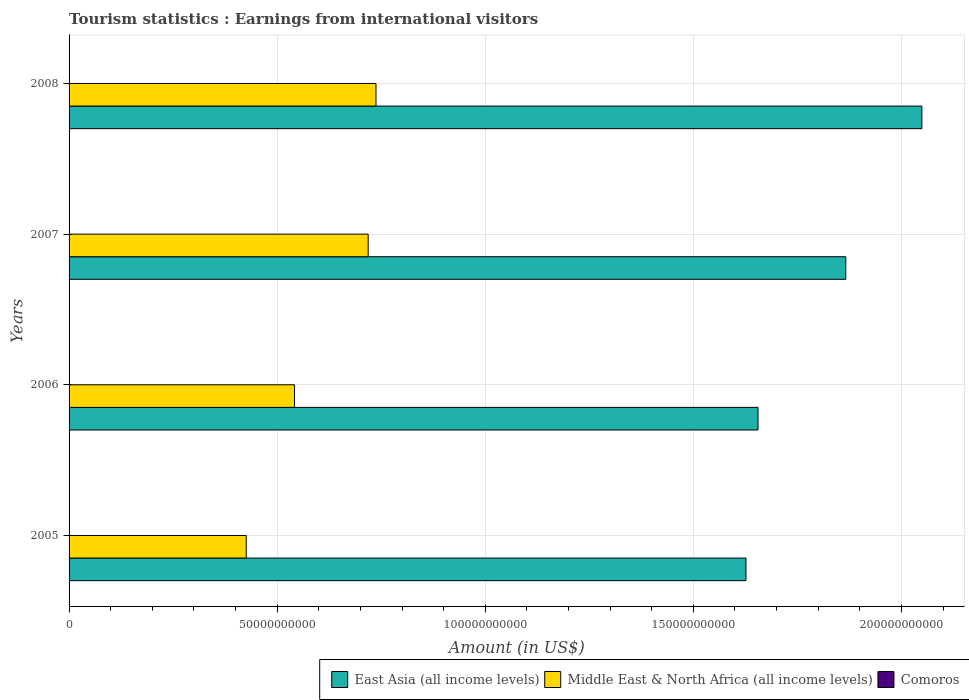Are the number of bars per tick equal to the number of legend labels?
Ensure brevity in your answer.  Yes. Are the number of bars on each tick of the Y-axis equal?
Provide a succinct answer. Yes. How many bars are there on the 2nd tick from the top?
Offer a very short reply. 3. How many bars are there on the 4th tick from the bottom?
Ensure brevity in your answer.  3. What is the label of the 4th group of bars from the top?
Keep it short and to the point. 2005. In how many cases, is the number of bars for a given year not equal to the number of legend labels?
Your answer should be very brief. 0. What is the earnings from international visitors in East Asia (all income levels) in 2007?
Keep it short and to the point. 1.87e+11. Across all years, what is the maximum earnings from international visitors in Comoros?
Your response must be concise. 3.10e+07. Across all years, what is the minimum earnings from international visitors in East Asia (all income levels)?
Offer a very short reply. 1.63e+11. In which year was the earnings from international visitors in Middle East & North Africa (all income levels) maximum?
Offer a very short reply. 2008. What is the total earnings from international visitors in East Asia (all income levels) in the graph?
Give a very brief answer. 7.20e+11. What is the difference between the earnings from international visitors in Comoros in 2005 and that in 2006?
Offer a very short reply. -4.00e+06. What is the difference between the earnings from international visitors in Middle East & North Africa (all income levels) in 2005 and the earnings from international visitors in East Asia (all income levels) in 2007?
Give a very brief answer. -1.44e+11. What is the average earnings from international visitors in East Asia (all income levels) per year?
Your answer should be very brief. 1.80e+11. In the year 2007, what is the difference between the earnings from international visitors in Middle East & North Africa (all income levels) and earnings from international visitors in East Asia (all income levels)?
Your answer should be compact. -1.15e+11. What is the ratio of the earnings from international visitors in Middle East & North Africa (all income levels) in 2005 to that in 2007?
Provide a succinct answer. 0.59. What is the difference between the highest and the second highest earnings from international visitors in Middle East & North Africa (all income levels)?
Make the answer very short. 1.88e+09. What is the difference between the highest and the lowest earnings from international visitors in Middle East & North Africa (all income levels)?
Your response must be concise. 3.12e+1. Is the sum of the earnings from international visitors in East Asia (all income levels) in 2005 and 2006 greater than the maximum earnings from international visitors in Comoros across all years?
Your response must be concise. Yes. What does the 1st bar from the top in 2006 represents?
Provide a short and direct response. Comoros. What does the 3rd bar from the bottom in 2006 represents?
Make the answer very short. Comoros. Is it the case that in every year, the sum of the earnings from international visitors in Middle East & North Africa (all income levels) and earnings from international visitors in East Asia (all income levels) is greater than the earnings from international visitors in Comoros?
Your response must be concise. Yes. How many bars are there?
Keep it short and to the point. 12. How many years are there in the graph?
Make the answer very short. 4. Are the values on the major ticks of X-axis written in scientific E-notation?
Ensure brevity in your answer.  No. Does the graph contain any zero values?
Ensure brevity in your answer.  No. Where does the legend appear in the graph?
Ensure brevity in your answer.  Bottom right. How many legend labels are there?
Provide a succinct answer. 3. What is the title of the graph?
Offer a terse response. Tourism statistics : Earnings from international visitors. What is the label or title of the X-axis?
Your answer should be very brief. Amount (in US$). What is the Amount (in US$) of East Asia (all income levels) in 2005?
Offer a very short reply. 1.63e+11. What is the Amount (in US$) in Middle East & North Africa (all income levels) in 2005?
Ensure brevity in your answer.  4.26e+1. What is the Amount (in US$) of East Asia (all income levels) in 2006?
Ensure brevity in your answer.  1.66e+11. What is the Amount (in US$) in Middle East & North Africa (all income levels) in 2006?
Your answer should be very brief. 5.42e+1. What is the Amount (in US$) in Comoros in 2006?
Give a very brief answer. 2.40e+07. What is the Amount (in US$) in East Asia (all income levels) in 2007?
Offer a very short reply. 1.87e+11. What is the Amount (in US$) of Middle East & North Africa (all income levels) in 2007?
Offer a very short reply. 7.19e+1. What is the Amount (in US$) in Comoros in 2007?
Offer a terse response. 2.80e+07. What is the Amount (in US$) in East Asia (all income levels) in 2008?
Make the answer very short. 2.05e+11. What is the Amount (in US$) of Middle East & North Africa (all income levels) in 2008?
Your answer should be compact. 7.37e+1. What is the Amount (in US$) of Comoros in 2008?
Provide a short and direct response. 3.10e+07. Across all years, what is the maximum Amount (in US$) of East Asia (all income levels)?
Make the answer very short. 2.05e+11. Across all years, what is the maximum Amount (in US$) of Middle East & North Africa (all income levels)?
Your answer should be very brief. 7.37e+1. Across all years, what is the maximum Amount (in US$) of Comoros?
Your answer should be very brief. 3.10e+07. Across all years, what is the minimum Amount (in US$) in East Asia (all income levels)?
Keep it short and to the point. 1.63e+11. Across all years, what is the minimum Amount (in US$) in Middle East & North Africa (all income levels)?
Make the answer very short. 4.26e+1. What is the total Amount (in US$) of East Asia (all income levels) in the graph?
Your answer should be very brief. 7.20e+11. What is the total Amount (in US$) in Middle East & North Africa (all income levels) in the graph?
Give a very brief answer. 2.42e+11. What is the total Amount (in US$) in Comoros in the graph?
Offer a very short reply. 1.03e+08. What is the difference between the Amount (in US$) in East Asia (all income levels) in 2005 and that in 2006?
Keep it short and to the point. -2.89e+09. What is the difference between the Amount (in US$) of Middle East & North Africa (all income levels) in 2005 and that in 2006?
Keep it short and to the point. -1.16e+1. What is the difference between the Amount (in US$) of Comoros in 2005 and that in 2006?
Provide a succinct answer. -4.00e+06. What is the difference between the Amount (in US$) in East Asia (all income levels) in 2005 and that in 2007?
Your answer should be very brief. -2.40e+1. What is the difference between the Amount (in US$) of Middle East & North Africa (all income levels) in 2005 and that in 2007?
Your response must be concise. -2.93e+1. What is the difference between the Amount (in US$) in Comoros in 2005 and that in 2007?
Your answer should be very brief. -8.00e+06. What is the difference between the Amount (in US$) of East Asia (all income levels) in 2005 and that in 2008?
Your answer should be very brief. -4.23e+1. What is the difference between the Amount (in US$) in Middle East & North Africa (all income levels) in 2005 and that in 2008?
Your answer should be very brief. -3.12e+1. What is the difference between the Amount (in US$) in Comoros in 2005 and that in 2008?
Your response must be concise. -1.10e+07. What is the difference between the Amount (in US$) in East Asia (all income levels) in 2006 and that in 2007?
Your response must be concise. -2.11e+1. What is the difference between the Amount (in US$) of Middle East & North Africa (all income levels) in 2006 and that in 2007?
Provide a short and direct response. -1.77e+1. What is the difference between the Amount (in US$) of East Asia (all income levels) in 2006 and that in 2008?
Offer a very short reply. -3.94e+1. What is the difference between the Amount (in US$) of Middle East & North Africa (all income levels) in 2006 and that in 2008?
Provide a succinct answer. -1.96e+1. What is the difference between the Amount (in US$) in Comoros in 2006 and that in 2008?
Make the answer very short. -7.00e+06. What is the difference between the Amount (in US$) in East Asia (all income levels) in 2007 and that in 2008?
Keep it short and to the point. -1.83e+1. What is the difference between the Amount (in US$) in Middle East & North Africa (all income levels) in 2007 and that in 2008?
Keep it short and to the point. -1.88e+09. What is the difference between the Amount (in US$) in Comoros in 2007 and that in 2008?
Provide a succinct answer. -3.00e+06. What is the difference between the Amount (in US$) in East Asia (all income levels) in 2005 and the Amount (in US$) in Middle East & North Africa (all income levels) in 2006?
Your answer should be very brief. 1.08e+11. What is the difference between the Amount (in US$) in East Asia (all income levels) in 2005 and the Amount (in US$) in Comoros in 2006?
Provide a succinct answer. 1.63e+11. What is the difference between the Amount (in US$) of Middle East & North Africa (all income levels) in 2005 and the Amount (in US$) of Comoros in 2006?
Give a very brief answer. 4.25e+1. What is the difference between the Amount (in US$) of East Asia (all income levels) in 2005 and the Amount (in US$) of Middle East & North Africa (all income levels) in 2007?
Provide a short and direct response. 9.08e+1. What is the difference between the Amount (in US$) in East Asia (all income levels) in 2005 and the Amount (in US$) in Comoros in 2007?
Your answer should be very brief. 1.63e+11. What is the difference between the Amount (in US$) in Middle East & North Africa (all income levels) in 2005 and the Amount (in US$) in Comoros in 2007?
Offer a terse response. 4.25e+1. What is the difference between the Amount (in US$) of East Asia (all income levels) in 2005 and the Amount (in US$) of Middle East & North Africa (all income levels) in 2008?
Give a very brief answer. 8.89e+1. What is the difference between the Amount (in US$) of East Asia (all income levels) in 2005 and the Amount (in US$) of Comoros in 2008?
Keep it short and to the point. 1.63e+11. What is the difference between the Amount (in US$) in Middle East & North Africa (all income levels) in 2005 and the Amount (in US$) in Comoros in 2008?
Provide a short and direct response. 4.25e+1. What is the difference between the Amount (in US$) of East Asia (all income levels) in 2006 and the Amount (in US$) of Middle East & North Africa (all income levels) in 2007?
Offer a very short reply. 9.37e+1. What is the difference between the Amount (in US$) in East Asia (all income levels) in 2006 and the Amount (in US$) in Comoros in 2007?
Provide a short and direct response. 1.66e+11. What is the difference between the Amount (in US$) in Middle East & North Africa (all income levels) in 2006 and the Amount (in US$) in Comoros in 2007?
Your response must be concise. 5.41e+1. What is the difference between the Amount (in US$) in East Asia (all income levels) in 2006 and the Amount (in US$) in Middle East & North Africa (all income levels) in 2008?
Provide a short and direct response. 9.18e+1. What is the difference between the Amount (in US$) of East Asia (all income levels) in 2006 and the Amount (in US$) of Comoros in 2008?
Give a very brief answer. 1.66e+11. What is the difference between the Amount (in US$) of Middle East & North Africa (all income levels) in 2006 and the Amount (in US$) of Comoros in 2008?
Give a very brief answer. 5.41e+1. What is the difference between the Amount (in US$) of East Asia (all income levels) in 2007 and the Amount (in US$) of Middle East & North Africa (all income levels) in 2008?
Provide a short and direct response. 1.13e+11. What is the difference between the Amount (in US$) in East Asia (all income levels) in 2007 and the Amount (in US$) in Comoros in 2008?
Your answer should be compact. 1.87e+11. What is the difference between the Amount (in US$) of Middle East & North Africa (all income levels) in 2007 and the Amount (in US$) of Comoros in 2008?
Give a very brief answer. 7.18e+1. What is the average Amount (in US$) of East Asia (all income levels) per year?
Offer a terse response. 1.80e+11. What is the average Amount (in US$) in Middle East & North Africa (all income levels) per year?
Provide a short and direct response. 6.06e+1. What is the average Amount (in US$) of Comoros per year?
Offer a very short reply. 2.58e+07. In the year 2005, what is the difference between the Amount (in US$) in East Asia (all income levels) and Amount (in US$) in Middle East & North Africa (all income levels)?
Give a very brief answer. 1.20e+11. In the year 2005, what is the difference between the Amount (in US$) of East Asia (all income levels) and Amount (in US$) of Comoros?
Give a very brief answer. 1.63e+11. In the year 2005, what is the difference between the Amount (in US$) of Middle East & North Africa (all income levels) and Amount (in US$) of Comoros?
Your answer should be compact. 4.25e+1. In the year 2006, what is the difference between the Amount (in US$) in East Asia (all income levels) and Amount (in US$) in Middle East & North Africa (all income levels)?
Offer a very short reply. 1.11e+11. In the year 2006, what is the difference between the Amount (in US$) in East Asia (all income levels) and Amount (in US$) in Comoros?
Ensure brevity in your answer.  1.66e+11. In the year 2006, what is the difference between the Amount (in US$) in Middle East & North Africa (all income levels) and Amount (in US$) in Comoros?
Ensure brevity in your answer.  5.41e+1. In the year 2007, what is the difference between the Amount (in US$) in East Asia (all income levels) and Amount (in US$) in Middle East & North Africa (all income levels)?
Make the answer very short. 1.15e+11. In the year 2007, what is the difference between the Amount (in US$) of East Asia (all income levels) and Amount (in US$) of Comoros?
Your answer should be compact. 1.87e+11. In the year 2007, what is the difference between the Amount (in US$) in Middle East & North Africa (all income levels) and Amount (in US$) in Comoros?
Your response must be concise. 7.18e+1. In the year 2008, what is the difference between the Amount (in US$) in East Asia (all income levels) and Amount (in US$) in Middle East & North Africa (all income levels)?
Offer a very short reply. 1.31e+11. In the year 2008, what is the difference between the Amount (in US$) of East Asia (all income levels) and Amount (in US$) of Comoros?
Ensure brevity in your answer.  2.05e+11. In the year 2008, what is the difference between the Amount (in US$) of Middle East & North Africa (all income levels) and Amount (in US$) of Comoros?
Provide a short and direct response. 7.37e+1. What is the ratio of the Amount (in US$) in East Asia (all income levels) in 2005 to that in 2006?
Your response must be concise. 0.98. What is the ratio of the Amount (in US$) in Middle East & North Africa (all income levels) in 2005 to that in 2006?
Give a very brief answer. 0.79. What is the ratio of the Amount (in US$) of East Asia (all income levels) in 2005 to that in 2007?
Provide a short and direct response. 0.87. What is the ratio of the Amount (in US$) of Middle East & North Africa (all income levels) in 2005 to that in 2007?
Ensure brevity in your answer.  0.59. What is the ratio of the Amount (in US$) in East Asia (all income levels) in 2005 to that in 2008?
Make the answer very short. 0.79. What is the ratio of the Amount (in US$) of Middle East & North Africa (all income levels) in 2005 to that in 2008?
Offer a very short reply. 0.58. What is the ratio of the Amount (in US$) of Comoros in 2005 to that in 2008?
Make the answer very short. 0.65. What is the ratio of the Amount (in US$) in East Asia (all income levels) in 2006 to that in 2007?
Provide a short and direct response. 0.89. What is the ratio of the Amount (in US$) in Middle East & North Africa (all income levels) in 2006 to that in 2007?
Give a very brief answer. 0.75. What is the ratio of the Amount (in US$) in East Asia (all income levels) in 2006 to that in 2008?
Ensure brevity in your answer.  0.81. What is the ratio of the Amount (in US$) of Middle East & North Africa (all income levels) in 2006 to that in 2008?
Give a very brief answer. 0.73. What is the ratio of the Amount (in US$) in Comoros in 2006 to that in 2008?
Give a very brief answer. 0.77. What is the ratio of the Amount (in US$) of East Asia (all income levels) in 2007 to that in 2008?
Keep it short and to the point. 0.91. What is the ratio of the Amount (in US$) of Middle East & North Africa (all income levels) in 2007 to that in 2008?
Provide a succinct answer. 0.97. What is the ratio of the Amount (in US$) of Comoros in 2007 to that in 2008?
Make the answer very short. 0.9. What is the difference between the highest and the second highest Amount (in US$) of East Asia (all income levels)?
Ensure brevity in your answer.  1.83e+1. What is the difference between the highest and the second highest Amount (in US$) in Middle East & North Africa (all income levels)?
Offer a terse response. 1.88e+09. What is the difference between the highest and the second highest Amount (in US$) of Comoros?
Ensure brevity in your answer.  3.00e+06. What is the difference between the highest and the lowest Amount (in US$) in East Asia (all income levels)?
Keep it short and to the point. 4.23e+1. What is the difference between the highest and the lowest Amount (in US$) of Middle East & North Africa (all income levels)?
Keep it short and to the point. 3.12e+1. What is the difference between the highest and the lowest Amount (in US$) of Comoros?
Provide a short and direct response. 1.10e+07. 